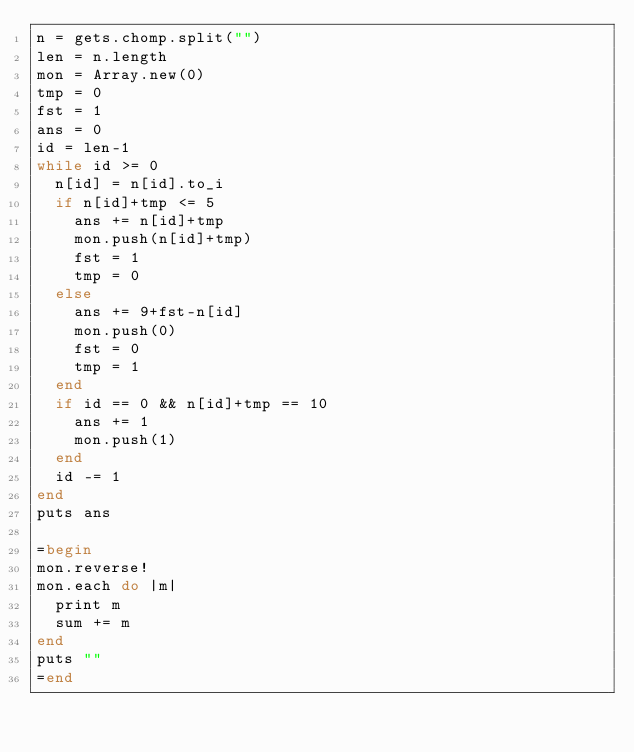<code> <loc_0><loc_0><loc_500><loc_500><_Ruby_>n = gets.chomp.split("")
len = n.length
mon = Array.new(0)
tmp = 0
fst = 1
ans = 0
id = len-1
while id >= 0
  n[id] = n[id].to_i
  if n[id]+tmp <= 5
    ans += n[id]+tmp
    mon.push(n[id]+tmp)
    fst = 1
    tmp = 0
  else
    ans += 9+fst-n[id]
    mon.push(0)
    fst = 0
    tmp = 1
  end
  if id == 0 && n[id]+tmp == 10
    ans += 1
    mon.push(1)
  end
  id -= 1
end
puts ans

=begin
mon.reverse!
mon.each do |m|
  print m
  sum += m
end
puts ""
=end</code> 